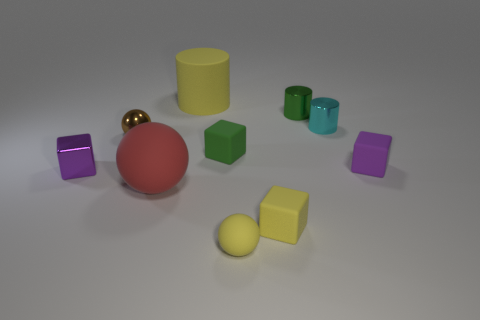There is a purple metallic thing that is the same size as the cyan metallic object; what is its shape? The purple metallic object that matches the size of the cyan object is a cube, featuring equal lengths on all its edges and displaying six square faces, each angled at 90 degrees relative to its adjacent faces. 